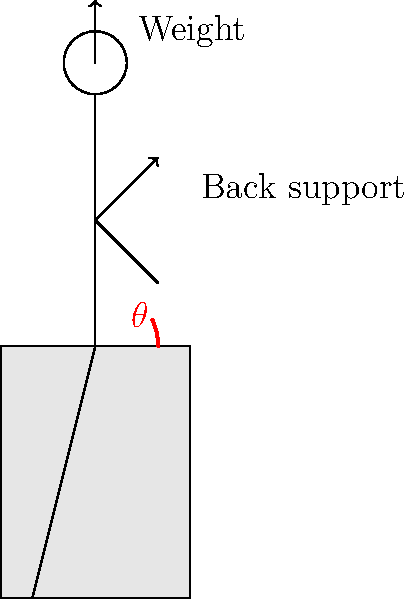During long travel periods, maintaining proper posture is crucial. Consider the biomechanics of sitting for extended durations. What is the recommended angle ($\theta$) between the upper body and thighs to minimize stress on the lower back, and how does this position distribute the body's weight to reduce fatigue? To understand the biomechanics of proper sitting posture during long travel periods, let's break it down step-by-step:

1. Recommended angle ($\theta$):
   The ideal angle between the upper body and thighs is approximately 110-130 degrees. This is often referred to as the "reclined sitting posture."

2. Weight distribution:
   a) In this position, the body's weight is more evenly distributed between the seat and the backrest.
   b) The pelvis rotates slightly backward, which helps maintain the natural curve of the lower spine (lordosis).

3. Stress reduction on lower back:
   a) The reclined position reduces the compressive forces on the intervertebral discs.
   b) It decreases the activity of the erector spinae muscles, reducing muscle fatigue.

4. Biomechanical advantages:
   a) Reduced shear forces on the lumbar spine.
   b) Decreased intradiscal pressure, which can help prevent disc degeneration.

5. Additional considerations:
   a) Use of lumbar support to maintain the natural curve of the spine.
   b) Adjusting the seat height so that feet are flat on the floor or a footrest.
   c) Keeping the knees at or slightly below hip level to reduce pressure on the back of the thighs.

6. Physiological benefits:
   a) Improved blood circulation in the lower limbs.
   b) Reduced risk of deep vein thrombosis during long trips.

By maintaining this posture, travelers can significantly reduce the risk of developing back pain and fatigue during long journeys, which is particularly important for frequent travelers or those in the travel business.
Answer: 110-130 degrees; evenly distributes weight between seat and backrest, reducing lower back stress and muscle fatigue. 